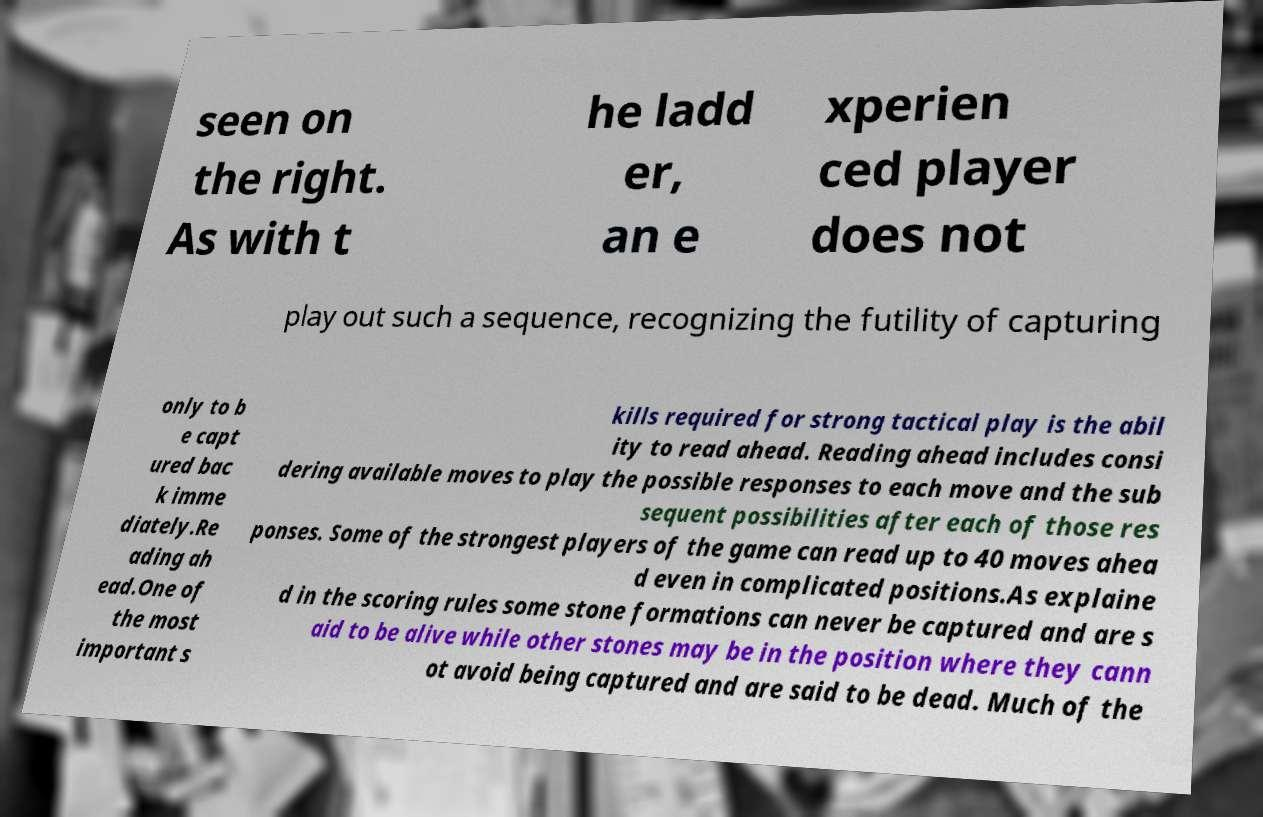Can you accurately transcribe the text from the provided image for me? seen on the right. As with t he ladd er, an e xperien ced player does not play out such a sequence, recognizing the futility of capturing only to b e capt ured bac k imme diately.Re ading ah ead.One of the most important s kills required for strong tactical play is the abil ity to read ahead. Reading ahead includes consi dering available moves to play the possible responses to each move and the sub sequent possibilities after each of those res ponses. Some of the strongest players of the game can read up to 40 moves ahea d even in complicated positions.As explaine d in the scoring rules some stone formations can never be captured and are s aid to be alive while other stones may be in the position where they cann ot avoid being captured and are said to be dead. Much of the 